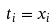Convert formula to latex. <formula><loc_0><loc_0><loc_500><loc_500>t _ { i } = x _ { i }</formula> 